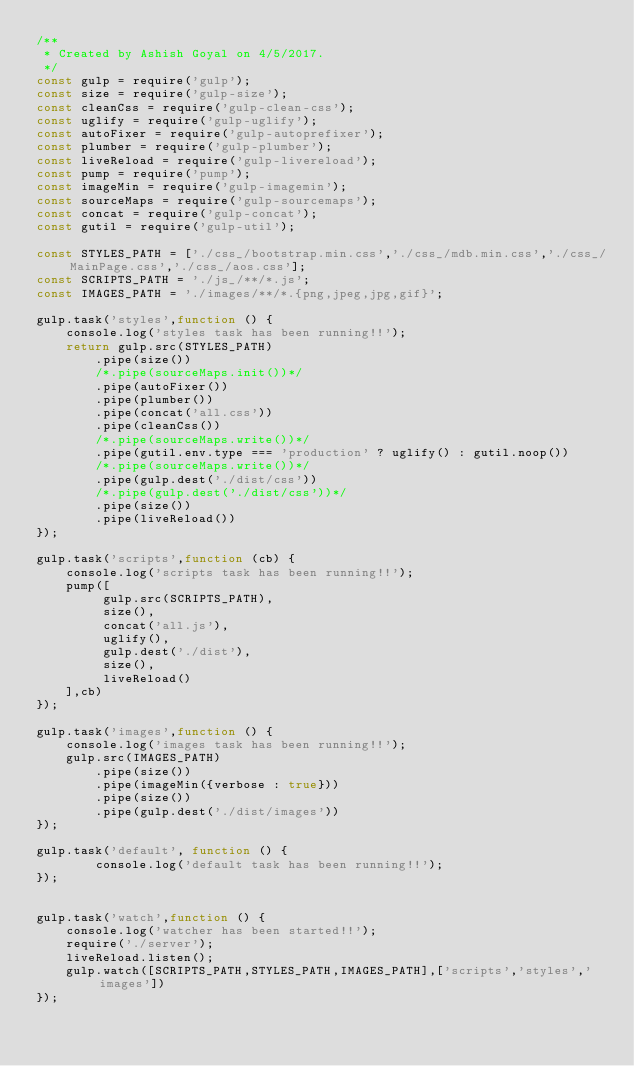<code> <loc_0><loc_0><loc_500><loc_500><_JavaScript_>/**
 * Created by Ashish Goyal on 4/5/2017.
 */
const gulp = require('gulp');
const size = require('gulp-size');
const cleanCss = require('gulp-clean-css');
const uglify = require('gulp-uglify');
const autoFixer = require('gulp-autoprefixer');
const plumber = require('gulp-plumber');
const liveReload = require('gulp-livereload');
const pump = require('pump');
const imageMin = require('gulp-imagemin');
const sourceMaps = require('gulp-sourcemaps');
const concat = require('gulp-concat');
const gutil = require('gulp-util');

const STYLES_PATH = ['./css_/bootstrap.min.css','./css_/mdb.min.css','./css_/MainPage.css','./css_/aos.css'];
const SCRIPTS_PATH = './js_/**/*.js';
const IMAGES_PATH = './images/**/*.{png,jpeg,jpg,gif}';

gulp.task('styles',function () {
    console.log('styles task has been running!!');
    return gulp.src(STYLES_PATH)
        .pipe(size())
        /*.pipe(sourceMaps.init())*/
        .pipe(autoFixer())
        .pipe(plumber())
        .pipe(concat('all.css'))
        .pipe(cleanCss())
        /*.pipe(sourceMaps.write())*/
        .pipe(gutil.env.type === 'production' ? uglify() : gutil.noop())
        /*.pipe(sourceMaps.write())*/
        .pipe(gulp.dest('./dist/css'))
        /*.pipe(gulp.dest('./dist/css'))*/
        .pipe(size())
        .pipe(liveReload())
});

gulp.task('scripts',function (cb) {
    console.log('scripts task has been running!!');
    pump([
         gulp.src(SCRIPTS_PATH),
         size(),
         concat('all.js'),
         uglify(),
         gulp.dest('./dist'),
         size(),
         liveReload()
    ],cb)
});

gulp.task('images',function () {
    console.log('images task has been running!!');
    gulp.src(IMAGES_PATH)
        .pipe(size())
        .pipe(imageMin({verbose : true}))
        .pipe(size())
        .pipe(gulp.dest('./dist/images'))
});

gulp.task('default', function () {
        console.log('default task has been running!!');
});


gulp.task('watch',function () {
    console.log('watcher has been started!!');
    require('./server');
    liveReload.listen();
    gulp.watch([SCRIPTS_PATH,STYLES_PATH,IMAGES_PATH],['scripts','styles','images'])
});
</code> 